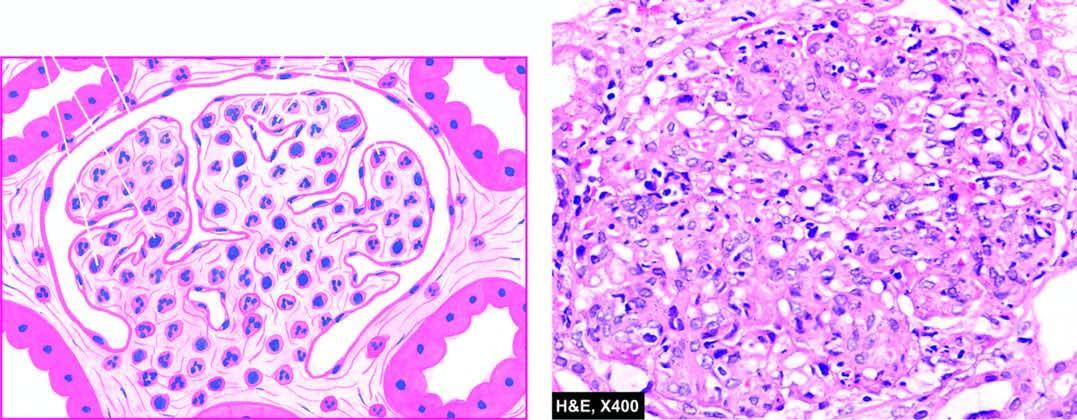s the epithelial element increased cellularity due to proliferation of mesangial cels, endothelial cells and some epithelial cells and infiltration of the tuft by neutrophils and monocytes?
Answer the question using a single word or phrase. No 